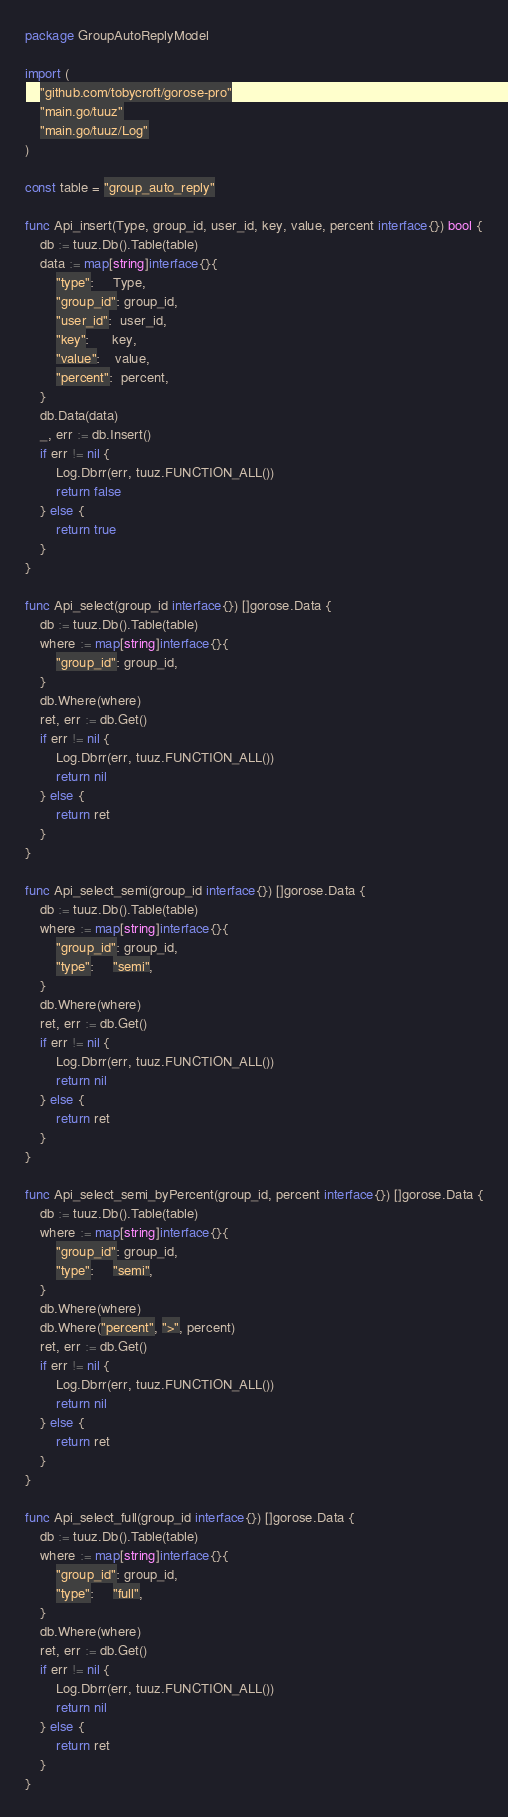<code> <loc_0><loc_0><loc_500><loc_500><_Go_>package GroupAutoReplyModel

import (
	"github.com/tobycroft/gorose-pro"
	"main.go/tuuz"
	"main.go/tuuz/Log"
)

const table = "group_auto_reply"

func Api_insert(Type, group_id, user_id, key, value, percent interface{}) bool {
	db := tuuz.Db().Table(table)
	data := map[string]interface{}{
		"type":     Type,
		"group_id": group_id,
		"user_id":  user_id,
		"key":      key,
		"value":    value,
		"percent":  percent,
	}
	db.Data(data)
	_, err := db.Insert()
	if err != nil {
		Log.Dbrr(err, tuuz.FUNCTION_ALL())
		return false
	} else {
		return true
	}
}

func Api_select(group_id interface{}) []gorose.Data {
	db := tuuz.Db().Table(table)
	where := map[string]interface{}{
		"group_id": group_id,
	}
	db.Where(where)
	ret, err := db.Get()
	if err != nil {
		Log.Dbrr(err, tuuz.FUNCTION_ALL())
		return nil
	} else {
		return ret
	}
}

func Api_select_semi(group_id interface{}) []gorose.Data {
	db := tuuz.Db().Table(table)
	where := map[string]interface{}{
		"group_id": group_id,
		"type":     "semi",
	}
	db.Where(where)
	ret, err := db.Get()
	if err != nil {
		Log.Dbrr(err, tuuz.FUNCTION_ALL())
		return nil
	} else {
		return ret
	}
}

func Api_select_semi_byPercent(group_id, percent interface{}) []gorose.Data {
	db := tuuz.Db().Table(table)
	where := map[string]interface{}{
		"group_id": group_id,
		"type":     "semi",
	}
	db.Where(where)
	db.Where("percent", ">", percent)
	ret, err := db.Get()
	if err != nil {
		Log.Dbrr(err, tuuz.FUNCTION_ALL())
		return nil
	} else {
		return ret
	}
}

func Api_select_full(group_id interface{}) []gorose.Data {
	db := tuuz.Db().Table(table)
	where := map[string]interface{}{
		"group_id": group_id,
		"type":     "full",
	}
	db.Where(where)
	ret, err := db.Get()
	if err != nil {
		Log.Dbrr(err, tuuz.FUNCTION_ALL())
		return nil
	} else {
		return ret
	}
}
</code> 